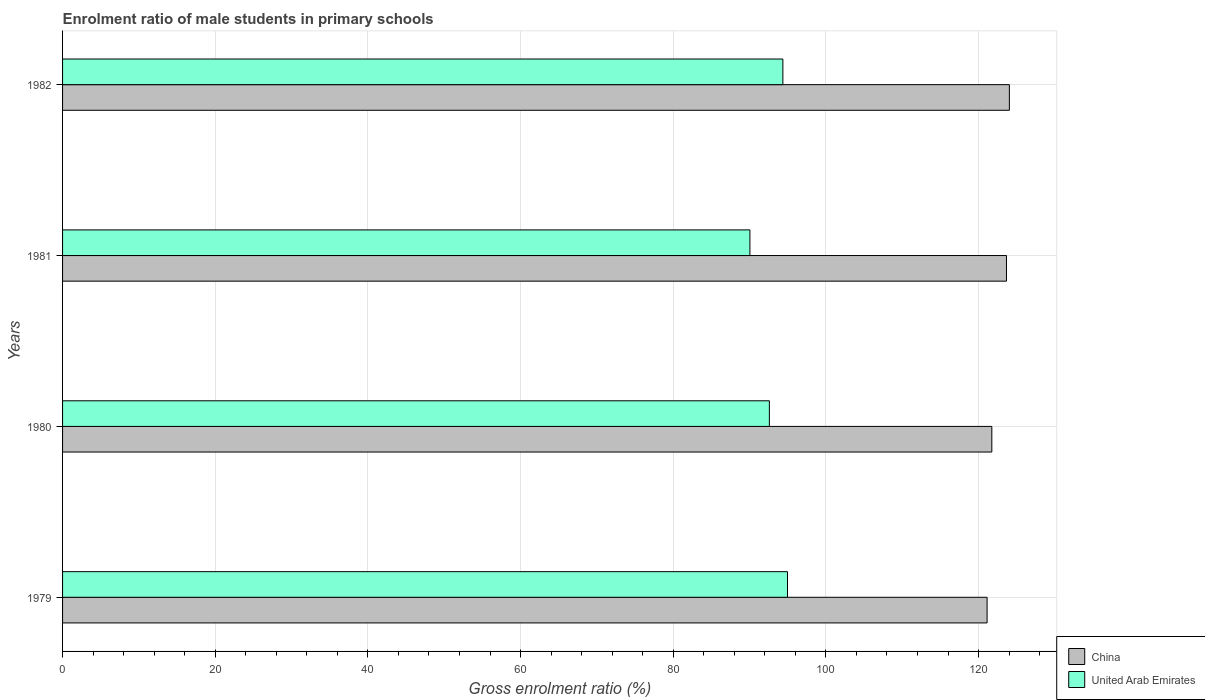How many different coloured bars are there?
Provide a succinct answer. 2. Are the number of bars on each tick of the Y-axis equal?
Ensure brevity in your answer.  Yes. How many bars are there on the 1st tick from the top?
Offer a terse response. 2. What is the label of the 4th group of bars from the top?
Keep it short and to the point. 1979. In how many cases, is the number of bars for a given year not equal to the number of legend labels?
Give a very brief answer. 0. What is the enrolment ratio of male students in primary schools in China in 1981?
Provide a short and direct response. 123.66. Across all years, what is the maximum enrolment ratio of male students in primary schools in United Arab Emirates?
Offer a very short reply. 94.97. Across all years, what is the minimum enrolment ratio of male students in primary schools in United Arab Emirates?
Provide a short and direct response. 90.04. In which year was the enrolment ratio of male students in primary schools in United Arab Emirates maximum?
Make the answer very short. 1979. In which year was the enrolment ratio of male students in primary schools in United Arab Emirates minimum?
Your answer should be compact. 1981. What is the total enrolment ratio of male students in primary schools in United Arab Emirates in the graph?
Provide a succinct answer. 371.97. What is the difference between the enrolment ratio of male students in primary schools in China in 1981 and that in 1982?
Offer a very short reply. -0.38. What is the difference between the enrolment ratio of male students in primary schools in China in 1979 and the enrolment ratio of male students in primary schools in United Arab Emirates in 1982?
Ensure brevity in your answer.  26.75. What is the average enrolment ratio of male students in primary schools in China per year?
Offer a very short reply. 122.63. In the year 1982, what is the difference between the enrolment ratio of male students in primary schools in China and enrolment ratio of male students in primary schools in United Arab Emirates?
Offer a very short reply. 29.67. What is the ratio of the enrolment ratio of male students in primary schools in United Arab Emirates in 1979 to that in 1980?
Your response must be concise. 1.03. What is the difference between the highest and the second highest enrolment ratio of male students in primary schools in China?
Provide a short and direct response. 0.38. What is the difference between the highest and the lowest enrolment ratio of male students in primary schools in United Arab Emirates?
Your answer should be compact. 4.93. In how many years, is the enrolment ratio of male students in primary schools in China greater than the average enrolment ratio of male students in primary schools in China taken over all years?
Provide a succinct answer. 2. What does the 1st bar from the top in 1982 represents?
Your answer should be compact. United Arab Emirates. What does the 2nd bar from the bottom in 1982 represents?
Keep it short and to the point. United Arab Emirates. Are all the bars in the graph horizontal?
Your answer should be very brief. Yes. Does the graph contain grids?
Give a very brief answer. Yes. Where does the legend appear in the graph?
Offer a very short reply. Bottom right. How many legend labels are there?
Offer a very short reply. 2. What is the title of the graph?
Give a very brief answer. Enrolment ratio of male students in primary schools. Does "Tuvalu" appear as one of the legend labels in the graph?
Make the answer very short. No. What is the Gross enrolment ratio (%) of China in 1979?
Offer a terse response. 121.11. What is the Gross enrolment ratio (%) in United Arab Emirates in 1979?
Your answer should be very brief. 94.97. What is the Gross enrolment ratio (%) in China in 1980?
Provide a short and direct response. 121.74. What is the Gross enrolment ratio (%) of United Arab Emirates in 1980?
Provide a short and direct response. 92.59. What is the Gross enrolment ratio (%) in China in 1981?
Ensure brevity in your answer.  123.66. What is the Gross enrolment ratio (%) in United Arab Emirates in 1981?
Keep it short and to the point. 90.04. What is the Gross enrolment ratio (%) of China in 1982?
Provide a succinct answer. 124.03. What is the Gross enrolment ratio (%) of United Arab Emirates in 1982?
Provide a short and direct response. 94.36. Across all years, what is the maximum Gross enrolment ratio (%) in China?
Ensure brevity in your answer.  124.03. Across all years, what is the maximum Gross enrolment ratio (%) in United Arab Emirates?
Offer a very short reply. 94.97. Across all years, what is the minimum Gross enrolment ratio (%) of China?
Provide a short and direct response. 121.11. Across all years, what is the minimum Gross enrolment ratio (%) in United Arab Emirates?
Make the answer very short. 90.04. What is the total Gross enrolment ratio (%) of China in the graph?
Offer a very short reply. 490.54. What is the total Gross enrolment ratio (%) of United Arab Emirates in the graph?
Keep it short and to the point. 371.97. What is the difference between the Gross enrolment ratio (%) of China in 1979 and that in 1980?
Ensure brevity in your answer.  -0.62. What is the difference between the Gross enrolment ratio (%) in United Arab Emirates in 1979 and that in 1980?
Your answer should be compact. 2.38. What is the difference between the Gross enrolment ratio (%) of China in 1979 and that in 1981?
Ensure brevity in your answer.  -2.54. What is the difference between the Gross enrolment ratio (%) in United Arab Emirates in 1979 and that in 1981?
Make the answer very short. 4.93. What is the difference between the Gross enrolment ratio (%) in China in 1979 and that in 1982?
Give a very brief answer. -2.92. What is the difference between the Gross enrolment ratio (%) in United Arab Emirates in 1979 and that in 1982?
Your response must be concise. 0.61. What is the difference between the Gross enrolment ratio (%) in China in 1980 and that in 1981?
Ensure brevity in your answer.  -1.92. What is the difference between the Gross enrolment ratio (%) in United Arab Emirates in 1980 and that in 1981?
Your answer should be very brief. 2.55. What is the difference between the Gross enrolment ratio (%) of China in 1980 and that in 1982?
Your response must be concise. -2.3. What is the difference between the Gross enrolment ratio (%) of United Arab Emirates in 1980 and that in 1982?
Ensure brevity in your answer.  -1.77. What is the difference between the Gross enrolment ratio (%) of China in 1981 and that in 1982?
Your response must be concise. -0.38. What is the difference between the Gross enrolment ratio (%) of United Arab Emirates in 1981 and that in 1982?
Provide a short and direct response. -4.32. What is the difference between the Gross enrolment ratio (%) in China in 1979 and the Gross enrolment ratio (%) in United Arab Emirates in 1980?
Make the answer very short. 28.52. What is the difference between the Gross enrolment ratio (%) of China in 1979 and the Gross enrolment ratio (%) of United Arab Emirates in 1981?
Offer a very short reply. 31.07. What is the difference between the Gross enrolment ratio (%) in China in 1979 and the Gross enrolment ratio (%) in United Arab Emirates in 1982?
Ensure brevity in your answer.  26.75. What is the difference between the Gross enrolment ratio (%) in China in 1980 and the Gross enrolment ratio (%) in United Arab Emirates in 1981?
Provide a short and direct response. 31.69. What is the difference between the Gross enrolment ratio (%) in China in 1980 and the Gross enrolment ratio (%) in United Arab Emirates in 1982?
Your response must be concise. 27.37. What is the difference between the Gross enrolment ratio (%) of China in 1981 and the Gross enrolment ratio (%) of United Arab Emirates in 1982?
Your answer should be compact. 29.29. What is the average Gross enrolment ratio (%) in China per year?
Ensure brevity in your answer.  122.63. What is the average Gross enrolment ratio (%) in United Arab Emirates per year?
Your answer should be compact. 92.99. In the year 1979, what is the difference between the Gross enrolment ratio (%) of China and Gross enrolment ratio (%) of United Arab Emirates?
Provide a succinct answer. 26.15. In the year 1980, what is the difference between the Gross enrolment ratio (%) in China and Gross enrolment ratio (%) in United Arab Emirates?
Offer a terse response. 29.14. In the year 1981, what is the difference between the Gross enrolment ratio (%) in China and Gross enrolment ratio (%) in United Arab Emirates?
Give a very brief answer. 33.61. In the year 1982, what is the difference between the Gross enrolment ratio (%) in China and Gross enrolment ratio (%) in United Arab Emirates?
Keep it short and to the point. 29.67. What is the ratio of the Gross enrolment ratio (%) of China in 1979 to that in 1980?
Offer a terse response. 0.99. What is the ratio of the Gross enrolment ratio (%) of United Arab Emirates in 1979 to that in 1980?
Your answer should be very brief. 1.03. What is the ratio of the Gross enrolment ratio (%) in China in 1979 to that in 1981?
Give a very brief answer. 0.98. What is the ratio of the Gross enrolment ratio (%) in United Arab Emirates in 1979 to that in 1981?
Offer a very short reply. 1.05. What is the ratio of the Gross enrolment ratio (%) in China in 1979 to that in 1982?
Provide a short and direct response. 0.98. What is the ratio of the Gross enrolment ratio (%) in United Arab Emirates in 1979 to that in 1982?
Your response must be concise. 1.01. What is the ratio of the Gross enrolment ratio (%) of China in 1980 to that in 1981?
Give a very brief answer. 0.98. What is the ratio of the Gross enrolment ratio (%) in United Arab Emirates in 1980 to that in 1981?
Your answer should be compact. 1.03. What is the ratio of the Gross enrolment ratio (%) of China in 1980 to that in 1982?
Provide a short and direct response. 0.98. What is the ratio of the Gross enrolment ratio (%) in United Arab Emirates in 1980 to that in 1982?
Ensure brevity in your answer.  0.98. What is the ratio of the Gross enrolment ratio (%) of China in 1981 to that in 1982?
Ensure brevity in your answer.  1. What is the ratio of the Gross enrolment ratio (%) of United Arab Emirates in 1981 to that in 1982?
Offer a terse response. 0.95. What is the difference between the highest and the second highest Gross enrolment ratio (%) in China?
Your answer should be compact. 0.38. What is the difference between the highest and the second highest Gross enrolment ratio (%) of United Arab Emirates?
Ensure brevity in your answer.  0.61. What is the difference between the highest and the lowest Gross enrolment ratio (%) of China?
Give a very brief answer. 2.92. What is the difference between the highest and the lowest Gross enrolment ratio (%) of United Arab Emirates?
Ensure brevity in your answer.  4.93. 